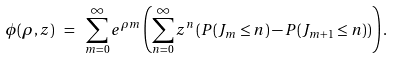<formula> <loc_0><loc_0><loc_500><loc_500>\phi ( \rho , z ) \ = \ \sum _ { m = 0 } ^ { \infty } e ^ { \rho m } \left ( \sum _ { n = 0 } ^ { \infty } z ^ { n } \left ( P ( J _ { m } \leq n ) - P ( J _ { m + 1 } \leq n ) \right ) \right ) .</formula> 